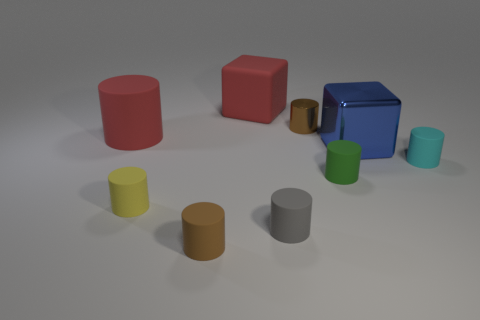Subtract all purple spheres. How many brown cylinders are left? 2 Subtract all brown cylinders. How many cylinders are left? 5 Add 1 red rubber balls. How many objects exist? 10 Subtract all yellow cylinders. How many cylinders are left? 6 Subtract 2 brown cylinders. How many objects are left? 7 Subtract all cylinders. How many objects are left? 2 Subtract all green cubes. Subtract all blue cylinders. How many cubes are left? 2 Subtract all big red cubes. Subtract all cylinders. How many objects are left? 1 Add 4 brown rubber objects. How many brown rubber objects are left? 5 Add 6 big brown rubber blocks. How many big brown rubber blocks exist? 6 